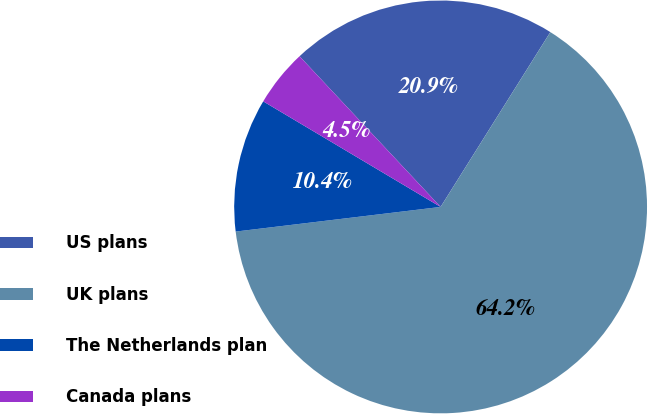<chart> <loc_0><loc_0><loc_500><loc_500><pie_chart><fcel>US plans<fcel>UK plans<fcel>The Netherlands plan<fcel>Canada plans<nl><fcel>20.9%<fcel>64.18%<fcel>10.45%<fcel>4.48%<nl></chart> 